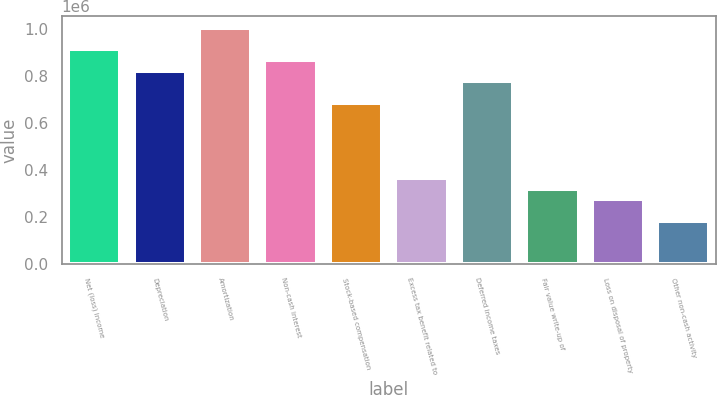<chart> <loc_0><loc_0><loc_500><loc_500><bar_chart><fcel>Net (loss) income<fcel>Depreciation<fcel>Amortization<fcel>Non-cash interest<fcel>Stock-based compensation<fcel>Excess tax benefit related to<fcel>Deferred income taxes<fcel>Fair value write-up of<fcel>Loss on disposal of property<fcel>Other non-cash activity<nl><fcel>911949<fcel>820764<fcel>1.00313e+06<fcel>866356<fcel>683986<fcel>364839<fcel>775172<fcel>319246<fcel>273654<fcel>182469<nl></chart> 